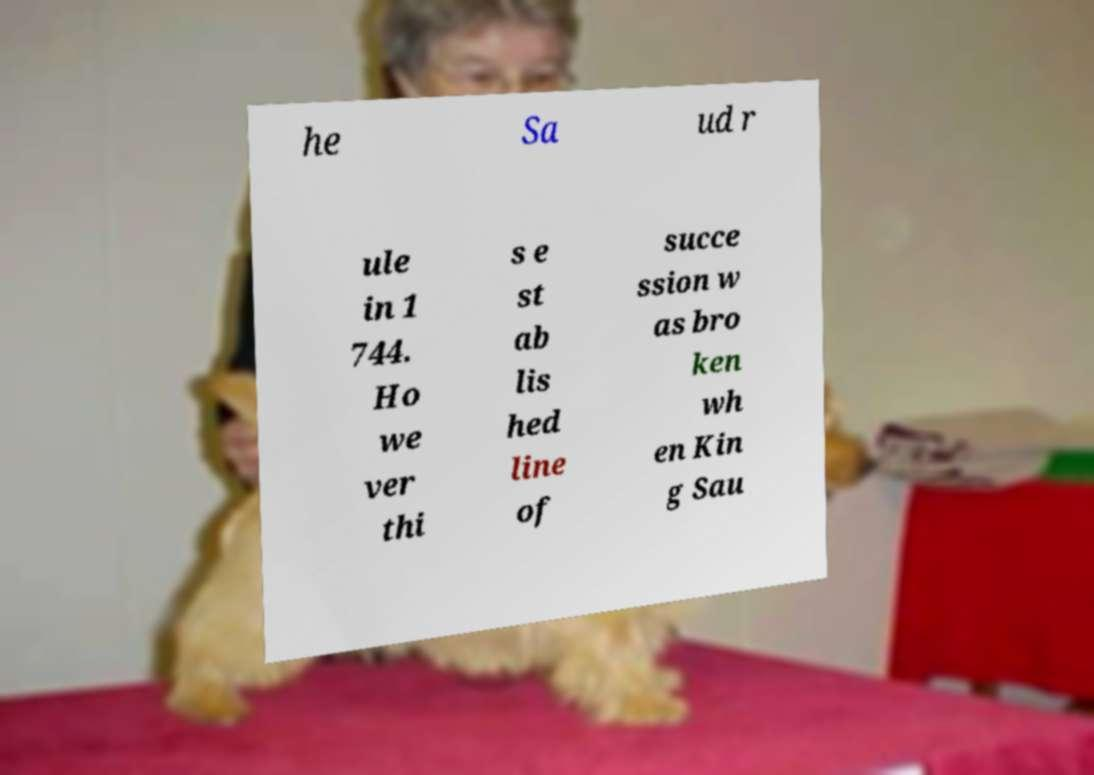Can you read and provide the text displayed in the image?This photo seems to have some interesting text. Can you extract and type it out for me? he Sa ud r ule in 1 744. Ho we ver thi s e st ab lis hed line of succe ssion w as bro ken wh en Kin g Sau 